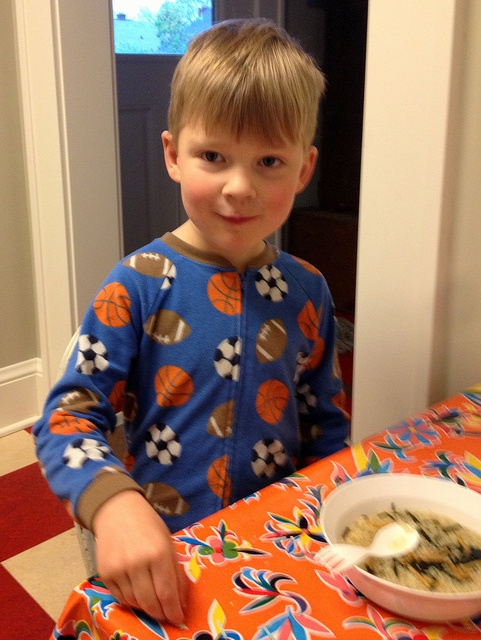Describe the objects in this image and their specific colors. I can see people in tan, black, brown, navy, and maroon tones, dining table in tan, red, and salmon tones, bowl in tan, beige, and olive tones, spoon in tan and lightyellow tones, and fork in tan and lightyellow tones in this image. 